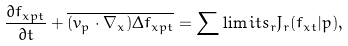<formula> <loc_0><loc_0><loc_500><loc_500>\frac { \partial f _ { { x } p t } } { \partial t } + \overline { ( { v } _ { p } \cdot \nabla _ { x } ) \Delta f _ { { x p } t } } = \sum \lim i t s _ { r } J _ { r } ( f _ { { x } t } | p ) ,</formula> 